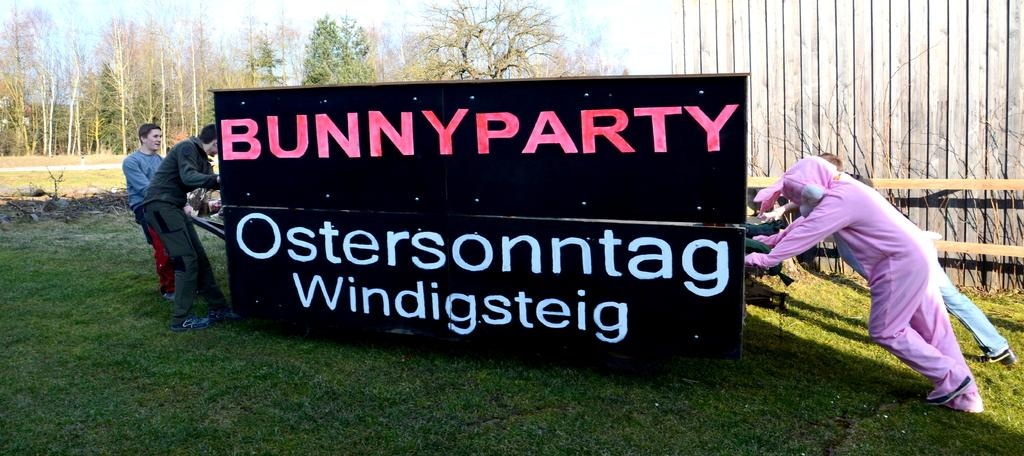What type of surface is on the ground in the image? There is grass on the ground in the image. What can be seen hanging or displayed in the image? There is a banner in the image. What are the people in the image doing with the banner? People are holding the banner in the image. What type of structure can be seen in the background of the image? There is a wooden wall in the background of the image. What natural elements are visible in the background of the image? Trees and the sky are visible in the background of the image. What type of jam is being spread on the rabbit's knee in the image? There is no rabbit or jam present in the image. 